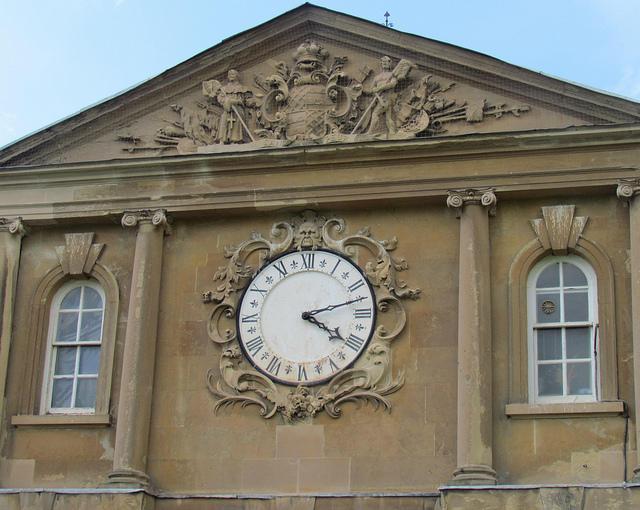How many windows are visible?
Give a very brief answer. 2. 